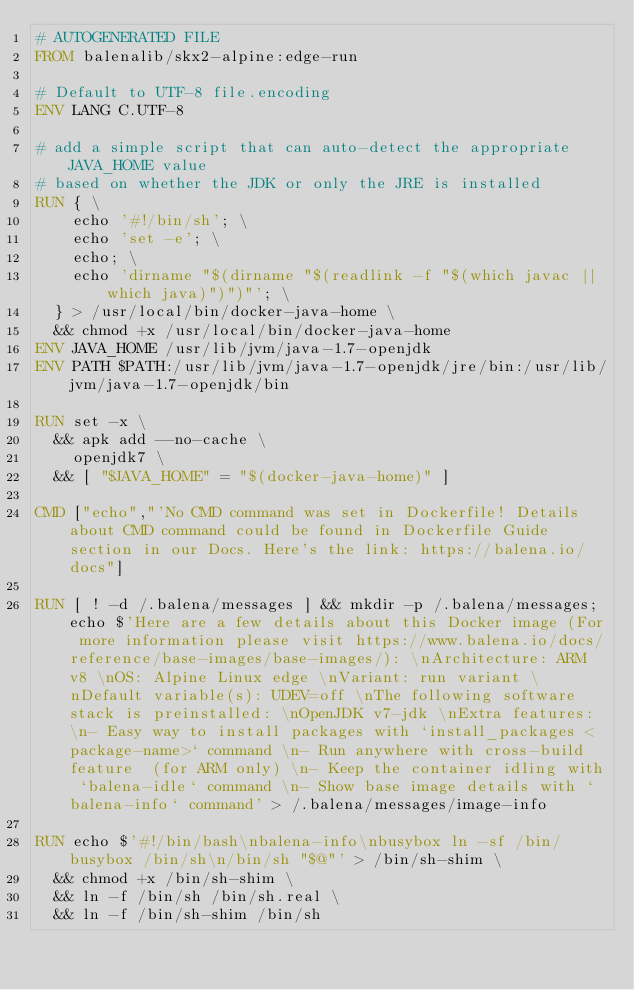Convert code to text. <code><loc_0><loc_0><loc_500><loc_500><_Dockerfile_># AUTOGENERATED FILE
FROM balenalib/skx2-alpine:edge-run

# Default to UTF-8 file.encoding
ENV LANG C.UTF-8

# add a simple script that can auto-detect the appropriate JAVA_HOME value
# based on whether the JDK or only the JRE is installed
RUN { \
		echo '#!/bin/sh'; \
		echo 'set -e'; \
		echo; \
		echo 'dirname "$(dirname "$(readlink -f "$(which javac || which java)")")"'; \
	} > /usr/local/bin/docker-java-home \
	&& chmod +x /usr/local/bin/docker-java-home
ENV JAVA_HOME /usr/lib/jvm/java-1.7-openjdk
ENV PATH $PATH:/usr/lib/jvm/java-1.7-openjdk/jre/bin:/usr/lib/jvm/java-1.7-openjdk/bin

RUN set -x \
	&& apk add --no-cache \
		openjdk7 \
	&& [ "$JAVA_HOME" = "$(docker-java-home)" ]

CMD ["echo","'No CMD command was set in Dockerfile! Details about CMD command could be found in Dockerfile Guide section in our Docs. Here's the link: https://balena.io/docs"]

RUN [ ! -d /.balena/messages ] && mkdir -p /.balena/messages; echo $'Here are a few details about this Docker image (For more information please visit https://www.balena.io/docs/reference/base-images/base-images/): \nArchitecture: ARM v8 \nOS: Alpine Linux edge \nVariant: run variant \nDefault variable(s): UDEV=off \nThe following software stack is preinstalled: \nOpenJDK v7-jdk \nExtra features: \n- Easy way to install packages with `install_packages <package-name>` command \n- Run anywhere with cross-build feature  (for ARM only) \n- Keep the container idling with `balena-idle` command \n- Show base image details with `balena-info` command' > /.balena/messages/image-info

RUN echo $'#!/bin/bash\nbalena-info\nbusybox ln -sf /bin/busybox /bin/sh\n/bin/sh "$@"' > /bin/sh-shim \
	&& chmod +x /bin/sh-shim \
	&& ln -f /bin/sh /bin/sh.real \
	&& ln -f /bin/sh-shim /bin/sh</code> 